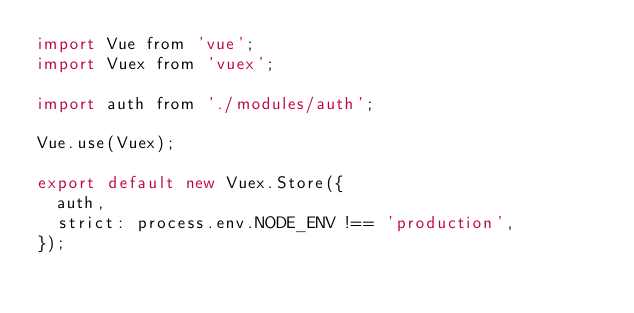Convert code to text. <code><loc_0><loc_0><loc_500><loc_500><_JavaScript_>import Vue from 'vue';
import Vuex from 'vuex';

import auth from './modules/auth';

Vue.use(Vuex);

export default new Vuex.Store({
  auth,
  strict: process.env.NODE_ENV !== 'production',
});
</code> 